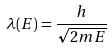<formula> <loc_0><loc_0><loc_500><loc_500>\lambda ( E ) = \frac { h } { \sqrt { 2 m E } }</formula> 